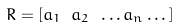<formula> <loc_0><loc_0><loc_500><loc_500>R = [ a _ { 1 } \ a _ { 2 } \ \dots a _ { n } \dots ]</formula> 